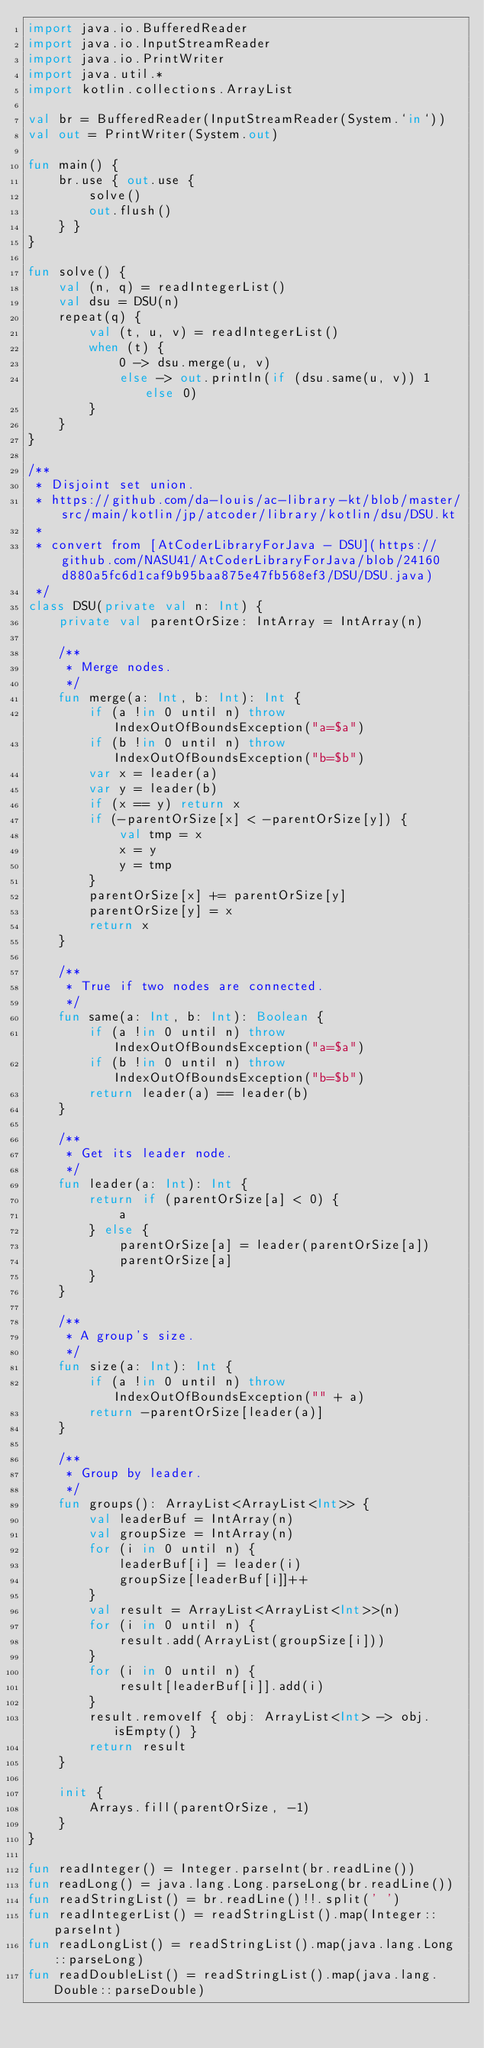<code> <loc_0><loc_0><loc_500><loc_500><_Kotlin_>import java.io.BufferedReader
import java.io.InputStreamReader
import java.io.PrintWriter
import java.util.*
import kotlin.collections.ArrayList

val br = BufferedReader(InputStreamReader(System.`in`))
val out = PrintWriter(System.out)

fun main() {
    br.use { out.use {
        solve()
        out.flush()
    } }
}

fun solve() {
    val (n, q) = readIntegerList()
    val dsu = DSU(n)
    repeat(q) {
        val (t, u, v) = readIntegerList()
        when (t) {
            0 -> dsu.merge(u, v)
            else -> out.println(if (dsu.same(u, v)) 1 else 0)
        }
    }
}

/**
 * Disjoint set union.
 * https://github.com/da-louis/ac-library-kt/blob/master/src/main/kotlin/jp/atcoder/library/kotlin/dsu/DSU.kt
 *
 * convert from [AtCoderLibraryForJava - DSU](https://github.com/NASU41/AtCoderLibraryForJava/blob/24160d880a5fc6d1caf9b95baa875e47fb568ef3/DSU/DSU.java)
 */
class DSU(private val n: Int) {
    private val parentOrSize: IntArray = IntArray(n)

    /**
     * Merge nodes.
     */
    fun merge(a: Int, b: Int): Int {
        if (a !in 0 until n) throw IndexOutOfBoundsException("a=$a")
        if (b !in 0 until n) throw IndexOutOfBoundsException("b=$b")
        var x = leader(a)
        var y = leader(b)
        if (x == y) return x
        if (-parentOrSize[x] < -parentOrSize[y]) {
            val tmp = x
            x = y
            y = tmp
        }
        parentOrSize[x] += parentOrSize[y]
        parentOrSize[y] = x
        return x
    }

    /**
     * True if two nodes are connected.
     */
    fun same(a: Int, b: Int): Boolean {
        if (a !in 0 until n) throw IndexOutOfBoundsException("a=$a")
        if (b !in 0 until n) throw IndexOutOfBoundsException("b=$b")
        return leader(a) == leader(b)
    }

    /**
     * Get its leader node.
     */
    fun leader(a: Int): Int {
        return if (parentOrSize[a] < 0) {
            a
        } else {
            parentOrSize[a] = leader(parentOrSize[a])
            parentOrSize[a]
        }
    }

    /**
     * A group's size.
     */
    fun size(a: Int): Int {
        if (a !in 0 until n) throw IndexOutOfBoundsException("" + a)
        return -parentOrSize[leader(a)]
    }

    /**
     * Group by leader.
     */
    fun groups(): ArrayList<ArrayList<Int>> {
        val leaderBuf = IntArray(n)
        val groupSize = IntArray(n)
        for (i in 0 until n) {
            leaderBuf[i] = leader(i)
            groupSize[leaderBuf[i]]++
        }
        val result = ArrayList<ArrayList<Int>>(n)
        for (i in 0 until n) {
            result.add(ArrayList(groupSize[i]))
        }
        for (i in 0 until n) {
            result[leaderBuf[i]].add(i)
        }
        result.removeIf { obj: ArrayList<Int> -> obj.isEmpty() }
        return result
    }

    init {
        Arrays.fill(parentOrSize, -1)
    }
}

fun readInteger() = Integer.parseInt(br.readLine())
fun readLong() = java.lang.Long.parseLong(br.readLine())
fun readStringList() = br.readLine()!!.split(' ')
fun readIntegerList() = readStringList().map(Integer::parseInt)
fun readLongList() = readStringList().map(java.lang.Long::parseLong)
fun readDoubleList() = readStringList().map(java.lang.Double::parseDouble)
</code> 